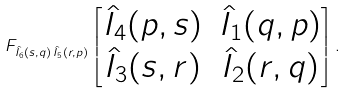Convert formula to latex. <formula><loc_0><loc_0><loc_500><loc_500>F _ { \hat { I } _ { 6 } ( s , q ) \, \hat { I } _ { 5 } ( r , p ) } \begin{bmatrix} \hat { I } _ { 4 } ( p , s ) & \hat { I } _ { 1 } ( q , p ) \\ \hat { I } _ { 3 } ( s , r ) & \hat { I } _ { 2 } ( r , q ) \end{bmatrix} .</formula> 